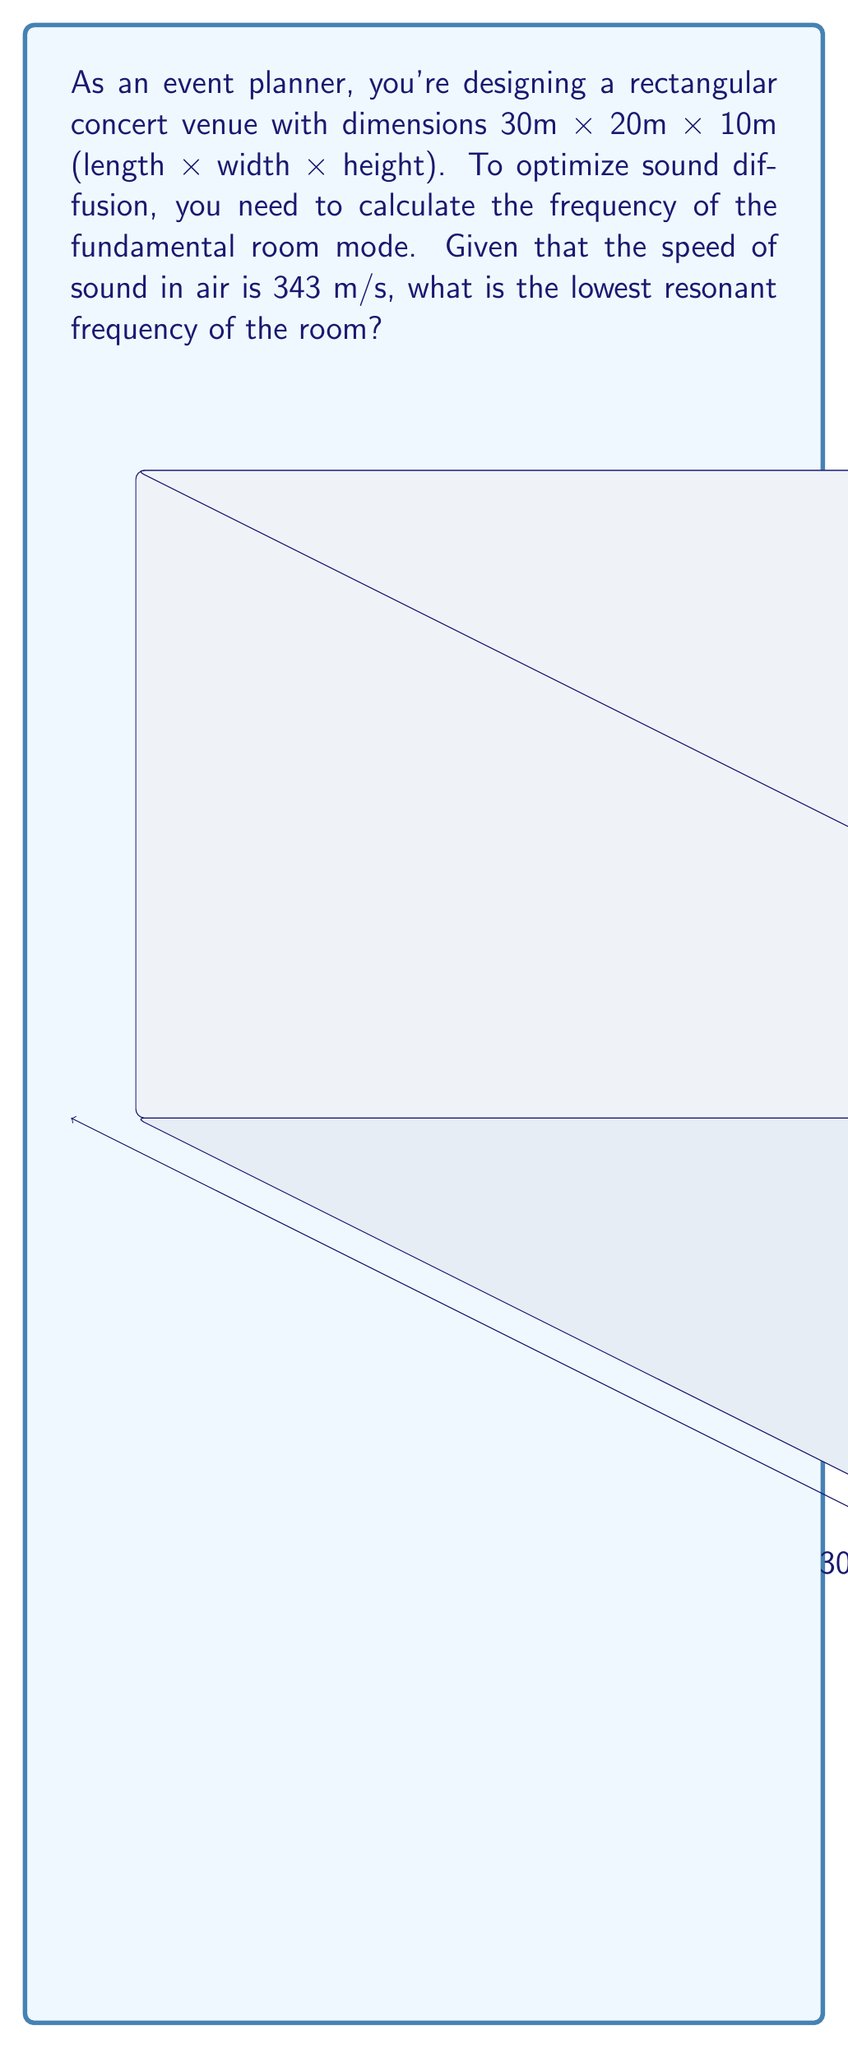Give your solution to this math problem. To solve this problem, we'll use the room mode formula derived from Fourier analysis:

$$ f = \frac{c}{2} \sqrt{\left(\frac{n_x}{L_x}\right)^2 + \left(\frac{n_y}{L_y}\right)^2 + \left(\frac{n_z}{L_z}\right)^2} $$

Where:
- $f$ is the resonant frequency
- $c$ is the speed of sound in air (343 m/s)
- $n_x$, $n_y$, and $n_z$ are integers representing the mode numbers (we'll use 1 for the fundamental mode)
- $L_x$, $L_y$, and $L_z$ are the room dimensions

Steps:
1) Identify the room dimensions:
   $L_x = 30$ m, $L_y = 20$ m, $L_z = 10$ m

2) For the fundamental mode, set $n_x = n_y = n_z = 1$

3) Substitute these values into the formula:

   $$ f = \frac{343}{2} \sqrt{\left(\frac{1}{30}\right)^2 + \left(\frac{1}{20}\right)^2 + \left(\frac{1}{10}\right)^2} $$

4) Simplify:
   $$ f = 171.5 \sqrt{\frac{1}{900} + \frac{1}{400} + \frac{1}{100}} $$
   $$ f = 171.5 \sqrt{0.00111 + 0.0025 + 0.01} $$
   $$ f = 171.5 \sqrt{0.01361} $$
   $$ f = 171.5 \times 0.1167 $$
   $$ f = 20.01 \text{ Hz} $$

5) Round to two decimal places: 20.01 Hz
Answer: 20.01 Hz 